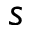<formula> <loc_0><loc_0><loc_500><loc_500>s</formula> 